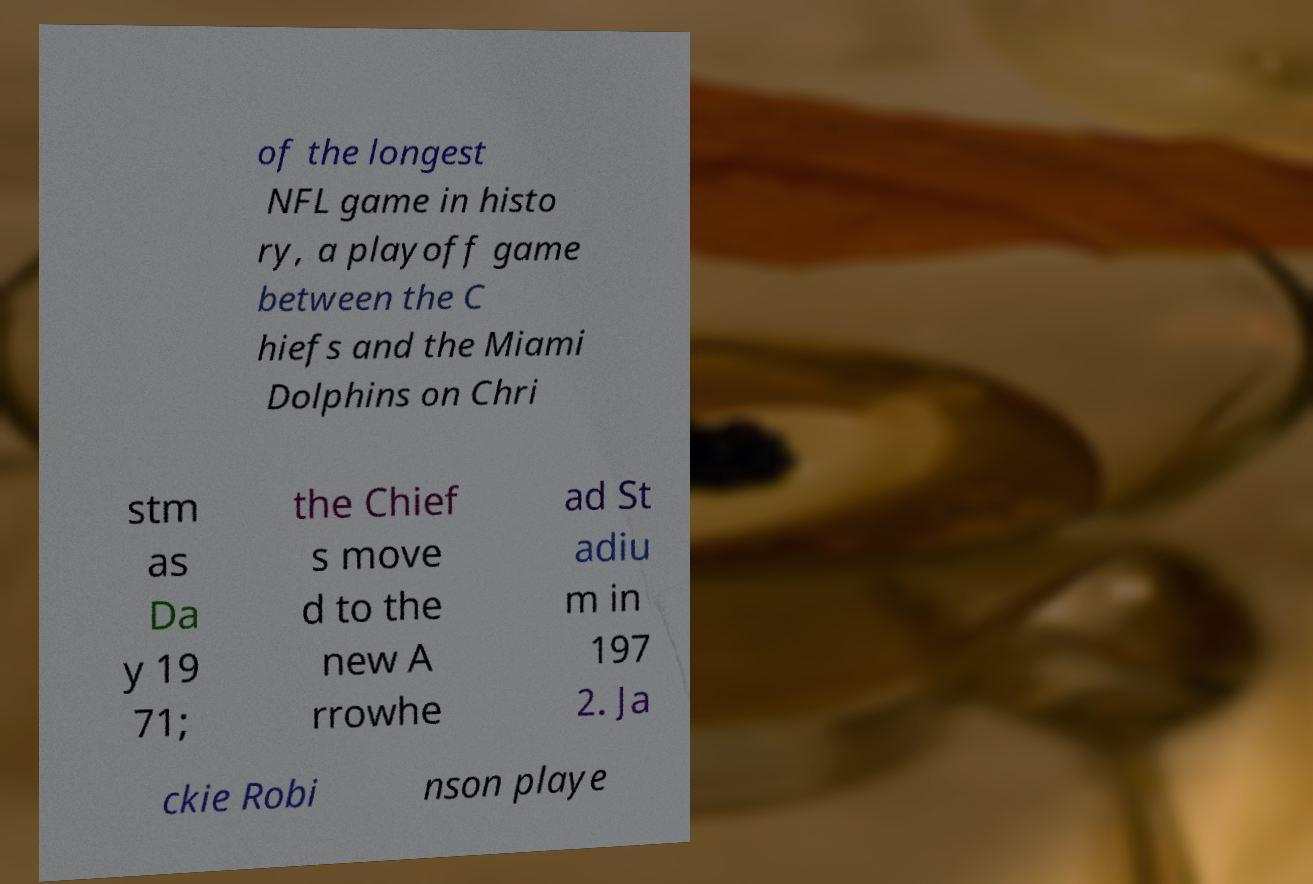Please read and relay the text visible in this image. What does it say? of the longest NFL game in histo ry, a playoff game between the C hiefs and the Miami Dolphins on Chri stm as Da y 19 71; the Chief s move d to the new A rrowhe ad St adiu m in 197 2. Ja ckie Robi nson playe 